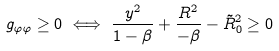<formula> <loc_0><loc_0><loc_500><loc_500>g _ { \varphi \varphi } \geq 0 \iff \frac { y ^ { 2 } } { 1 - \beta } + \frac { R ^ { 2 } } { - \beta } - \tilde { R } _ { 0 } ^ { 2 } \geq 0</formula> 